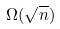Convert formula to latex. <formula><loc_0><loc_0><loc_500><loc_500>\Omega ( \sqrt { n } )</formula> 